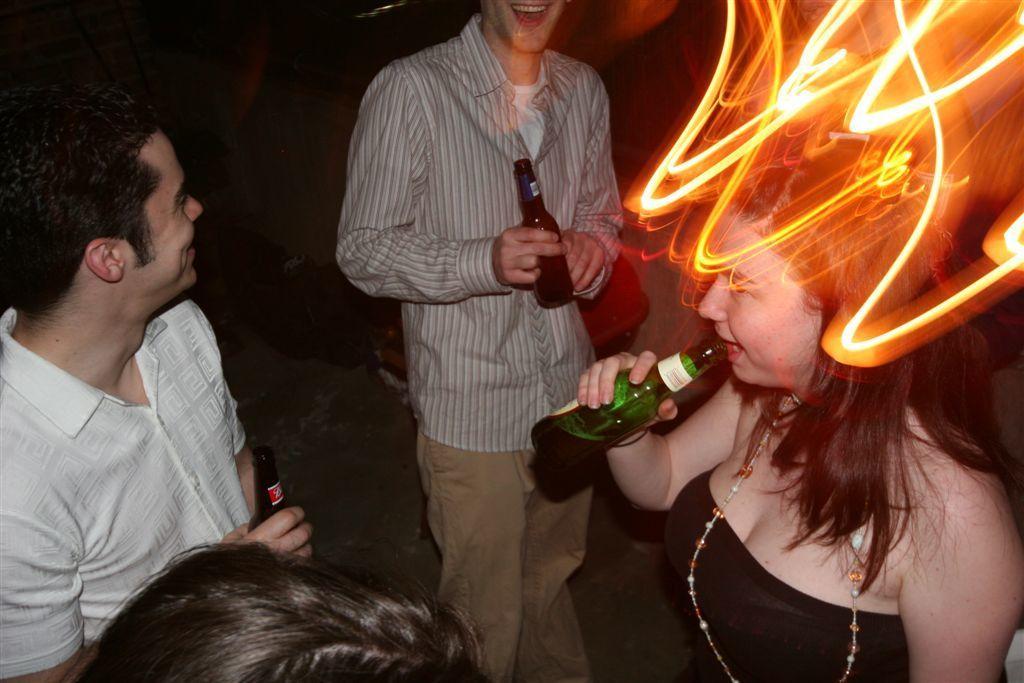Describe this image in one or two sentences. There are three persons standing and holding bottles. A woman on the right is wearing a pearl chain and drinking. Also there is a light on the head of her. 